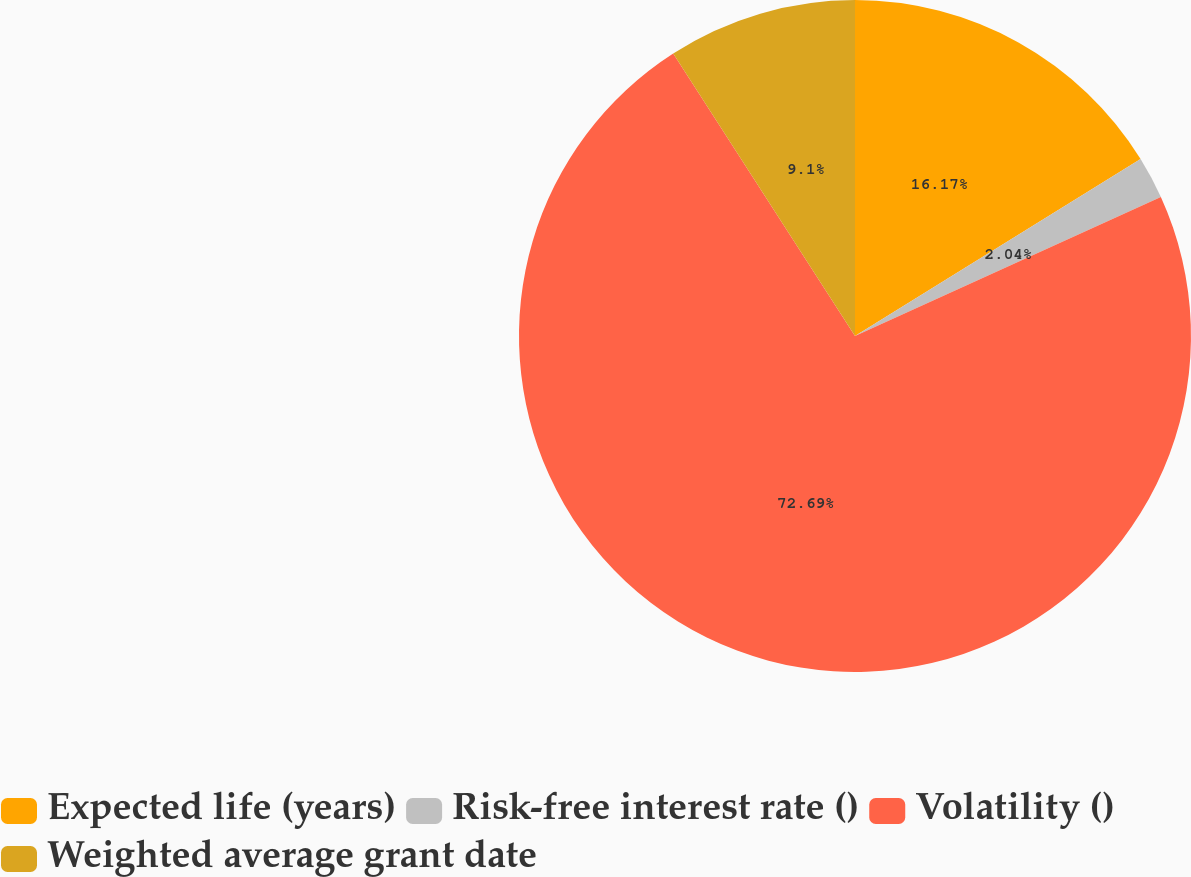Convert chart. <chart><loc_0><loc_0><loc_500><loc_500><pie_chart><fcel>Expected life (years)<fcel>Risk-free interest rate ()<fcel>Volatility ()<fcel>Weighted average grant date<nl><fcel>16.17%<fcel>2.04%<fcel>72.7%<fcel>9.1%<nl></chart> 